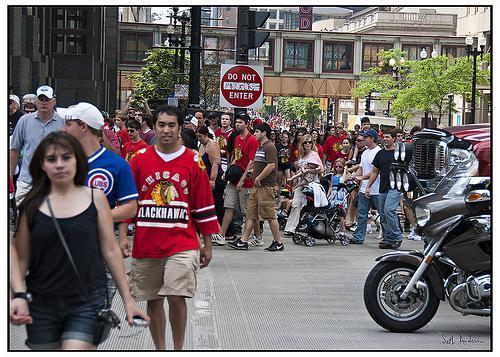How many motorcycles can be seen?
Give a very brief answer. 1. 